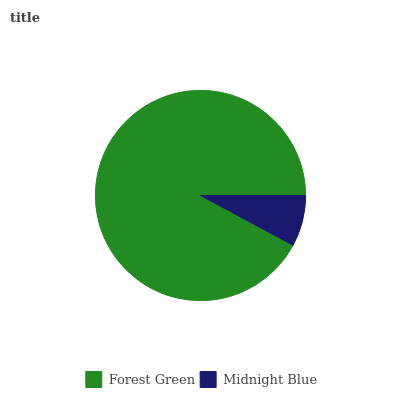Is Midnight Blue the minimum?
Answer yes or no. Yes. Is Forest Green the maximum?
Answer yes or no. Yes. Is Midnight Blue the maximum?
Answer yes or no. No. Is Forest Green greater than Midnight Blue?
Answer yes or no. Yes. Is Midnight Blue less than Forest Green?
Answer yes or no. Yes. Is Midnight Blue greater than Forest Green?
Answer yes or no. No. Is Forest Green less than Midnight Blue?
Answer yes or no. No. Is Forest Green the high median?
Answer yes or no. Yes. Is Midnight Blue the low median?
Answer yes or no. Yes. Is Midnight Blue the high median?
Answer yes or no. No. Is Forest Green the low median?
Answer yes or no. No. 